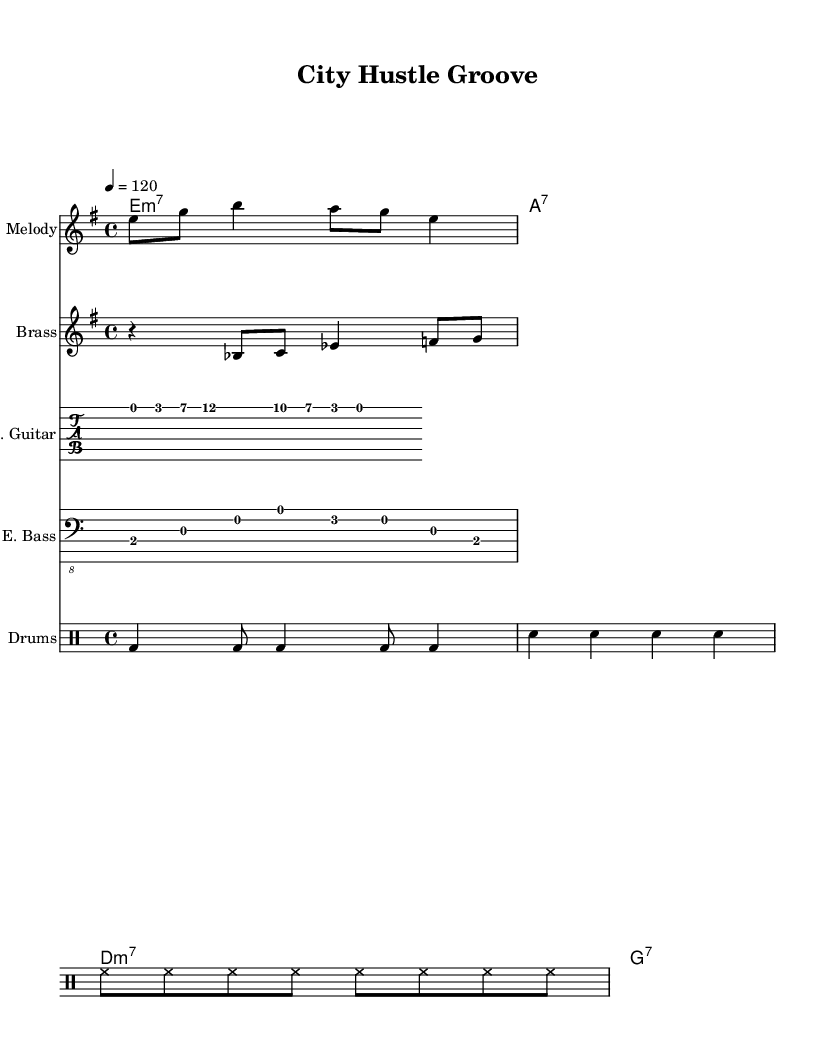What is the key signature of this music? The key signature is E minor, which has one sharp (F#). This information is indicated at the beginning of the staff where the key signature appears.
Answer: E minor What is the time signature of the piece? The time signature is 4/4, indicating that there are four beats in a measure and the quarter note gets one beat. This can be seen at the beginning of the staff.
Answer: 4/4 What is the tempo marking for this piece? The tempo marking is 120 beats per minute, shown above the staff, indicating that the section should be played at a brisk pace.
Answer: 120 How many measures are in the chords progression for the verse? The chords progression for the verse consists of four measures, each highlighted in the chord staff. The bars indicate the separation of each measure.
Answer: Four What type of instrument is playing the main melody? The main melody is played by a staff marked "Melody," which typically indicates a melodic instrument like a saxophone or flute in a funk context.
Answer: Melody How does the brass melody compare to the main melody in terms of note lengths? The brass melody has a mixture of quarter notes and eighth notes, while the main melody primarily consists of eighth notes and shorter rhythmic values, creating a contrast between the two. This can be analyzed by looking at the rhythmic notation.
Answer: Mixed lengths What is the primary genre of this composition? The composition is classified as Funk based on its rhythmic grooves, syncopation, and instrumentation, all of which are characteristic of Funk music. These attributes can be inferred from the overall style of the melodies and rhythms present in the score.
Answer: Funk 